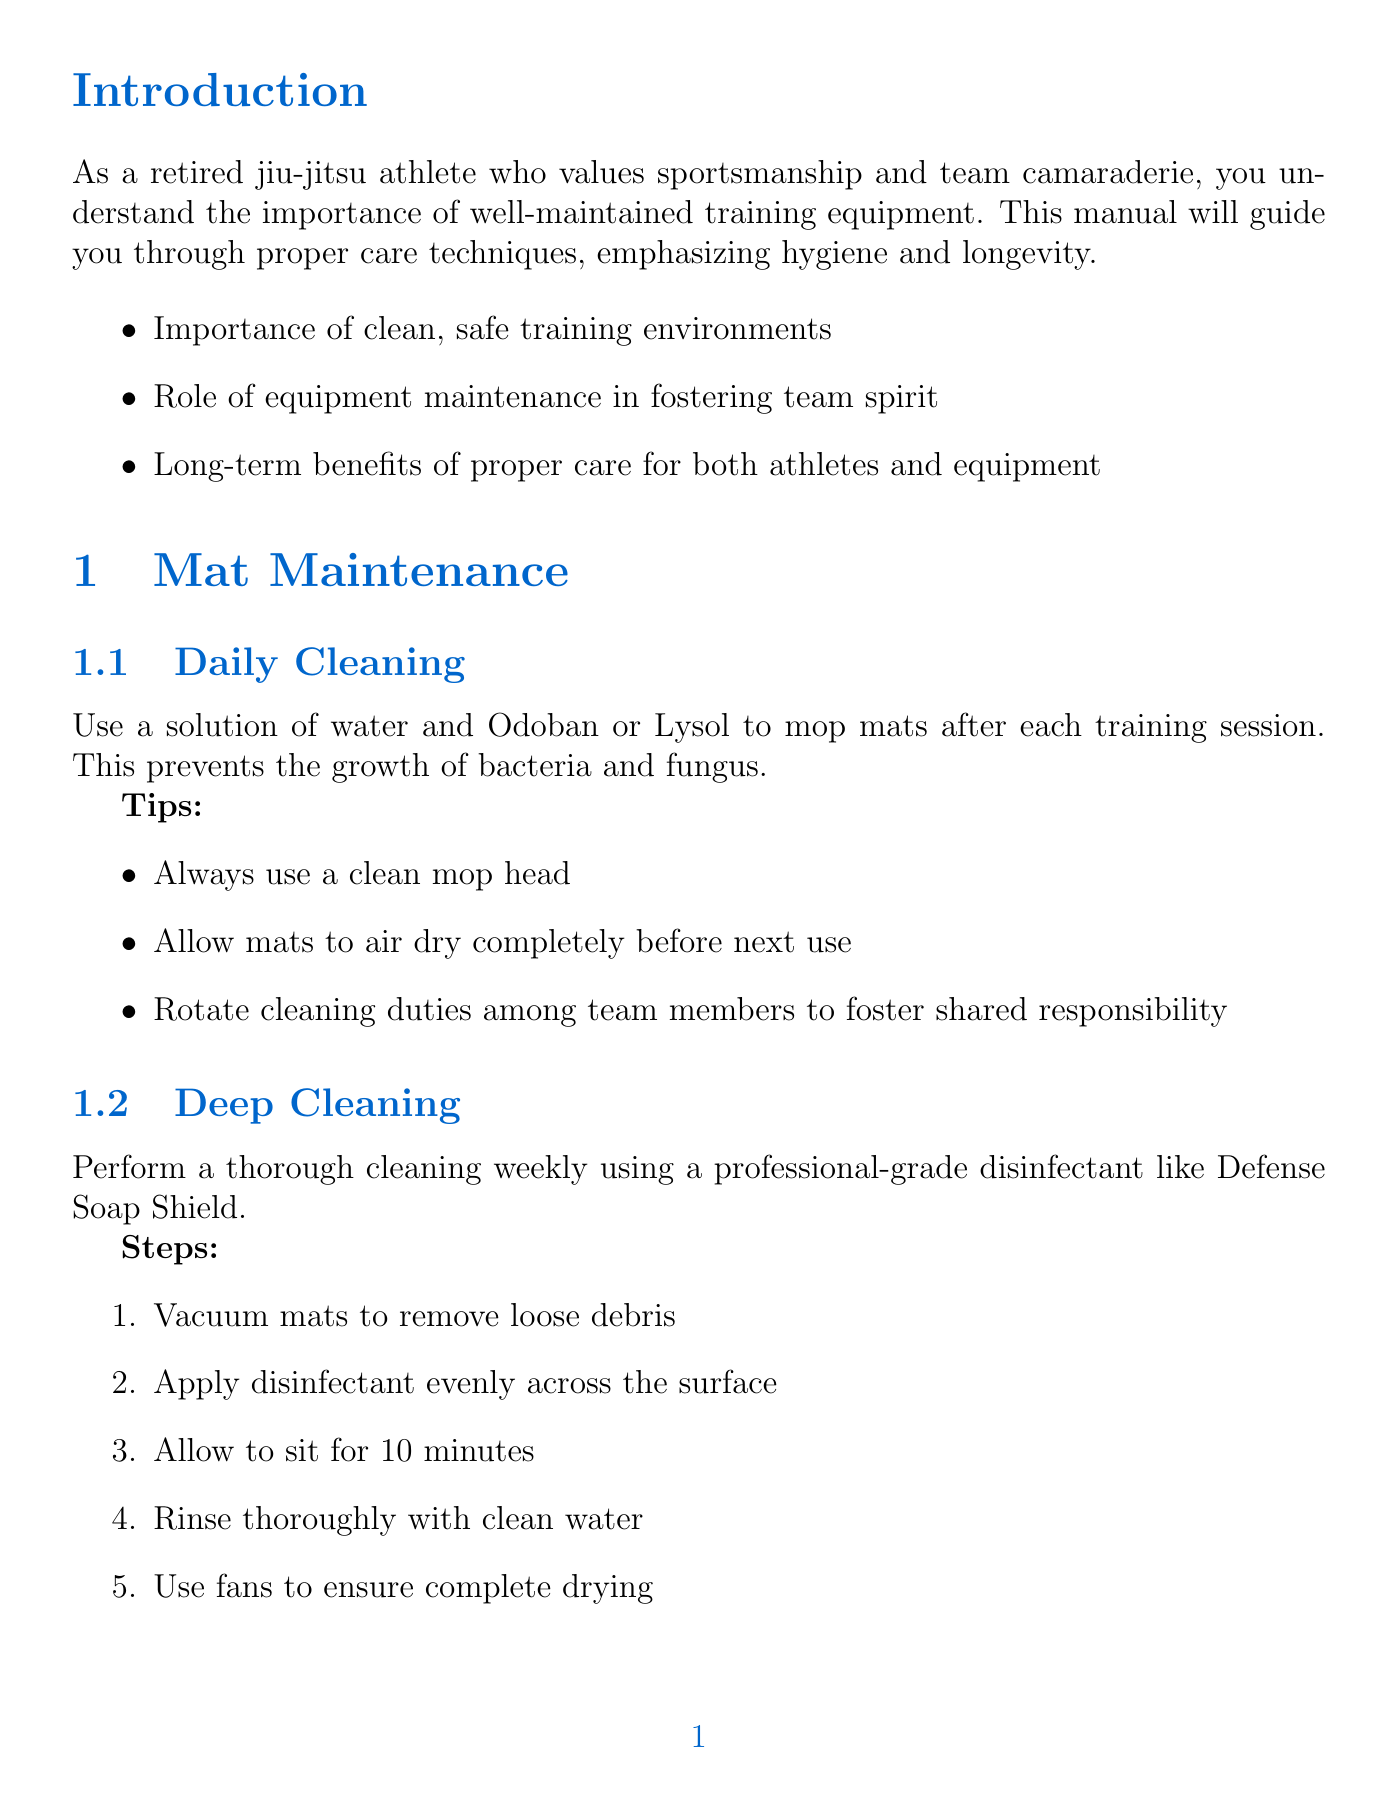What is the title of the manual? The title of the manual is provided at the beginning of the document.
Answer: Comprehensive Guide: Maintaining and Caring for Jiu-Jitsu Training Mats and Equipment How often should mats be deep cleaned? The manual specifies a frequency for deep cleaning of mats.
Answer: Weekly What product should be used for daily mat cleaning? The document recommends specific cleaning solutions for daily carpet care.
Answer: Odoban or Lysol What item is recommended for minor mat repairs? The manual mentions tools or materials suitable for repairing mats.
Answer: Dollamur Mat Tape Which area should gi and rash guards be stored? The document advises on suitable storage locations for equipment.
Answer: Well-ventilated area What should team members be educated about to promote hygiene? The manual includes specific hygiene topics for team education.
Answer: Personal hygiene How many steps are involved in weekly deep cleaning? The document outlines the cleaning procedure, indicating the number of steps included.
Answer: Five What is a suggested strategy for fostering shared responsibility? The manual provides strategies for encouraging teamwork in maintenance.
Answer: Develop a team-based cleaning and maintenance rotation What type of soap should be used to clean resistance bands? The manual specifies the type of soap for cleaning resistance bands.
Answer: Mild soap and water 